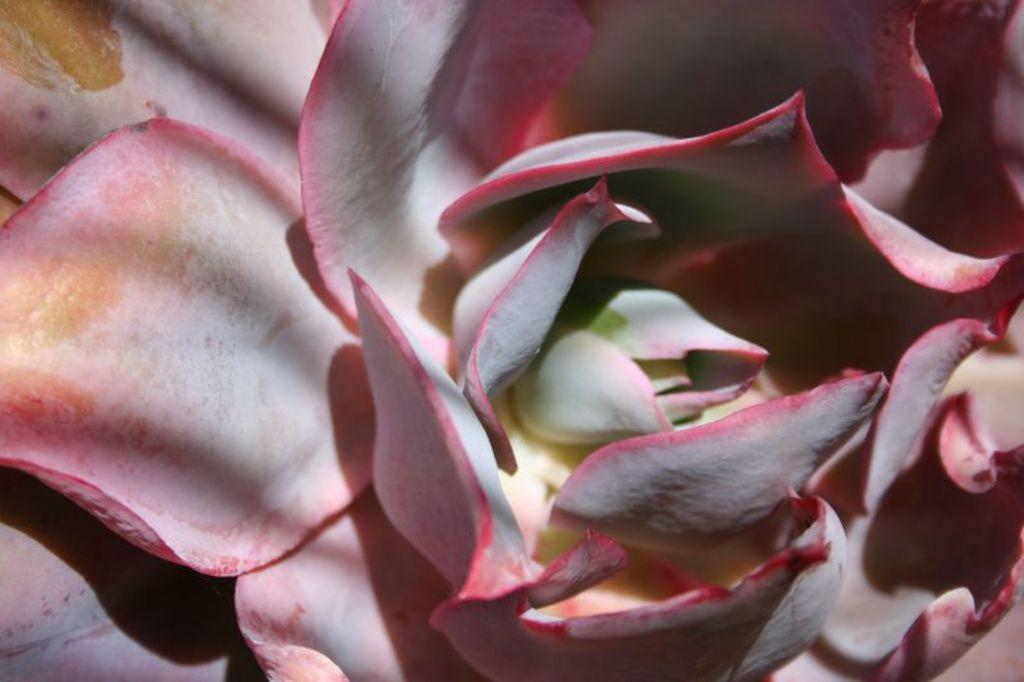What is the main subject of the image? There is a flower in the image. How close is the view of the flower in the image? The flower is in a close view. What color is the flower in the image? The flower is pink in color. What type of feast is being prepared in the background of the image? There is no feast or background visible in the image; it only features a close view of a pink flower. 